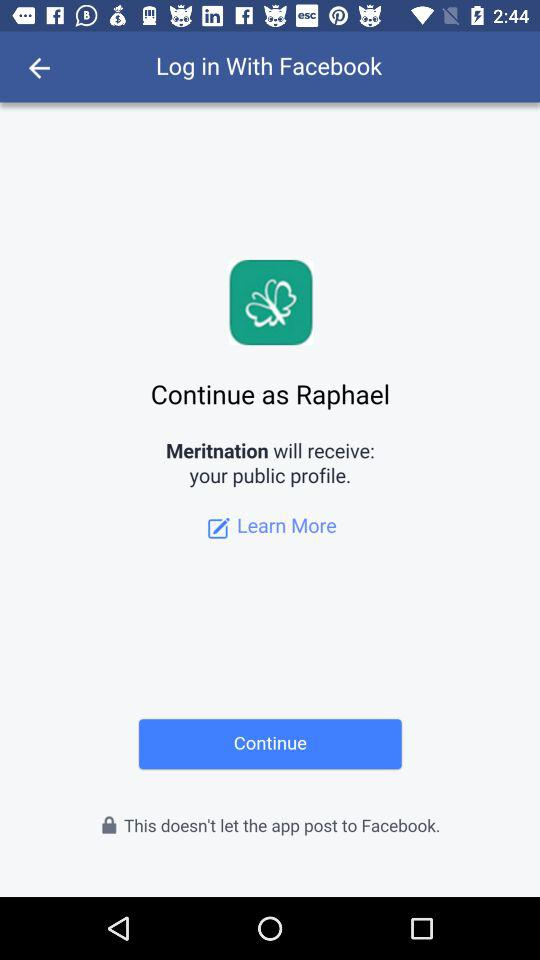What application will receive my public profile? The application that will receive your public profile is "Meritnation". 